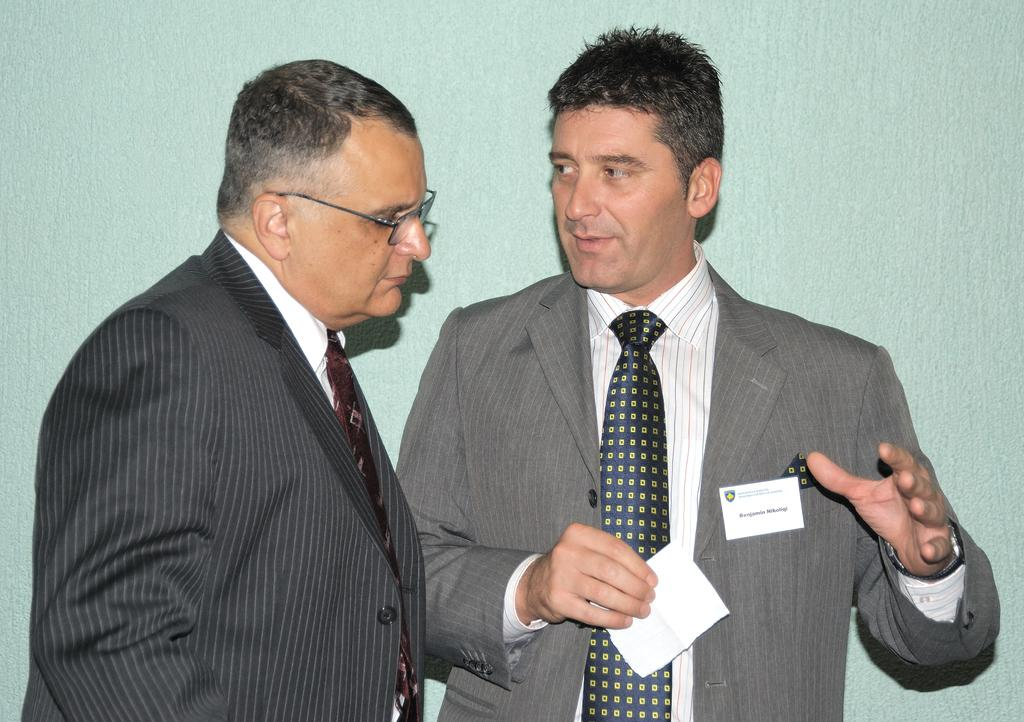How many people are in the image? There are two people standing in the center of the image. What is the man on the right holding? The man on the right is holding a paper in his hand. What can be seen in the background of the image? There is a wall in the background of the image. Is there a stream running through the image? No, there is no stream present in the image. Can you see any farm animals in the image? No, there are no farm animals visible in the image. 